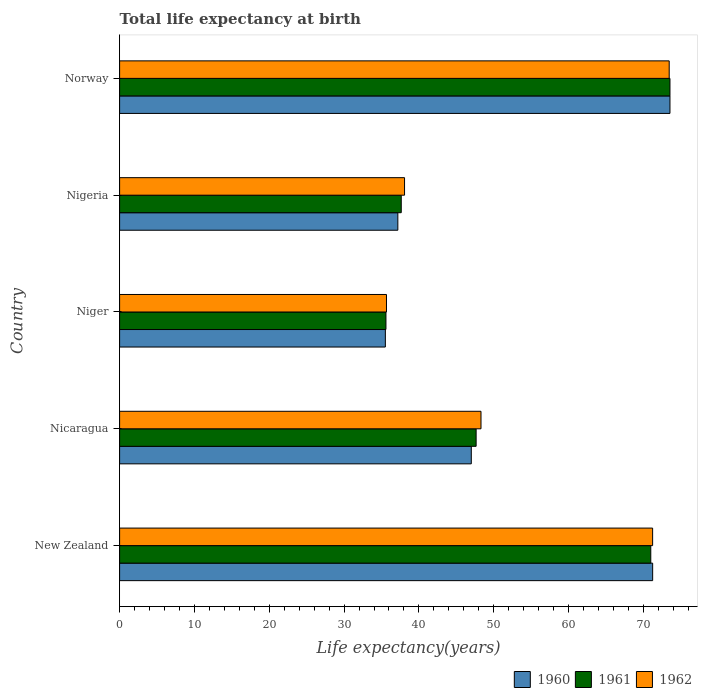How many bars are there on the 1st tick from the bottom?
Your answer should be very brief. 3. What is the label of the 3rd group of bars from the top?
Keep it short and to the point. Niger. In how many cases, is the number of bars for a given country not equal to the number of legend labels?
Give a very brief answer. 0. What is the life expectancy at birth in in 1962 in Nigeria?
Ensure brevity in your answer.  38.08. Across all countries, what is the maximum life expectancy at birth in in 1960?
Provide a short and direct response. 73.55. Across all countries, what is the minimum life expectancy at birth in in 1962?
Give a very brief answer. 35.67. In which country was the life expectancy at birth in in 1962 minimum?
Your answer should be very brief. Niger. What is the total life expectancy at birth in in 1962 in the graph?
Provide a short and direct response. 266.72. What is the difference between the life expectancy at birth in in 1962 in New Zealand and that in Nigeria?
Make the answer very short. 33.15. What is the difference between the life expectancy at birth in in 1960 in Nicaragua and the life expectancy at birth in in 1962 in Niger?
Offer a very short reply. 11.33. What is the average life expectancy at birth in in 1960 per country?
Your answer should be compact. 52.9. What is the difference between the life expectancy at birth in in 1960 and life expectancy at birth in in 1962 in Norway?
Your answer should be compact. 0.1. In how many countries, is the life expectancy at birth in in 1962 greater than 28 years?
Give a very brief answer. 5. What is the ratio of the life expectancy at birth in in 1960 in Nicaragua to that in Norway?
Offer a very short reply. 0.64. Is the difference between the life expectancy at birth in in 1960 in New Zealand and Nigeria greater than the difference between the life expectancy at birth in in 1962 in New Zealand and Nigeria?
Provide a short and direct response. Yes. What is the difference between the highest and the second highest life expectancy at birth in in 1962?
Give a very brief answer. 2.22. What is the difference between the highest and the lowest life expectancy at birth in in 1961?
Provide a short and direct response. 37.96. Is it the case that in every country, the sum of the life expectancy at birth in in 1962 and life expectancy at birth in in 1961 is greater than the life expectancy at birth in in 1960?
Your answer should be very brief. Yes. Are all the bars in the graph horizontal?
Make the answer very short. Yes. How many countries are there in the graph?
Offer a terse response. 5. Where does the legend appear in the graph?
Offer a terse response. Bottom right. How many legend labels are there?
Offer a very short reply. 3. What is the title of the graph?
Your response must be concise. Total life expectancy at birth. Does "1974" appear as one of the legend labels in the graph?
Your answer should be compact. No. What is the label or title of the X-axis?
Your answer should be compact. Life expectancy(years). What is the Life expectancy(years) in 1960 in New Zealand?
Offer a terse response. 71.24. What is the Life expectancy(years) in 1961 in New Zealand?
Provide a short and direct response. 70.99. What is the Life expectancy(years) in 1962 in New Zealand?
Offer a very short reply. 71.23. What is the Life expectancy(years) in 1960 in Nicaragua?
Provide a short and direct response. 47. What is the Life expectancy(years) of 1961 in Nicaragua?
Your response must be concise. 47.65. What is the Life expectancy(years) in 1962 in Nicaragua?
Give a very brief answer. 48.3. What is the Life expectancy(years) of 1960 in Niger?
Offer a terse response. 35.52. What is the Life expectancy(years) of 1961 in Niger?
Provide a succinct answer. 35.59. What is the Life expectancy(years) in 1962 in Niger?
Give a very brief answer. 35.67. What is the Life expectancy(years) of 1960 in Nigeria?
Provide a succinct answer. 37.18. What is the Life expectancy(years) of 1961 in Nigeria?
Keep it short and to the point. 37.64. What is the Life expectancy(years) of 1962 in Nigeria?
Your response must be concise. 38.08. What is the Life expectancy(years) in 1960 in Norway?
Your answer should be very brief. 73.55. What is the Life expectancy(years) of 1961 in Norway?
Keep it short and to the point. 73.55. What is the Life expectancy(years) of 1962 in Norway?
Offer a terse response. 73.45. Across all countries, what is the maximum Life expectancy(years) of 1960?
Provide a succinct answer. 73.55. Across all countries, what is the maximum Life expectancy(years) of 1961?
Offer a very short reply. 73.55. Across all countries, what is the maximum Life expectancy(years) in 1962?
Offer a very short reply. 73.45. Across all countries, what is the minimum Life expectancy(years) of 1960?
Give a very brief answer. 35.52. Across all countries, what is the minimum Life expectancy(years) in 1961?
Your answer should be very brief. 35.59. Across all countries, what is the minimum Life expectancy(years) in 1962?
Provide a short and direct response. 35.67. What is the total Life expectancy(years) in 1960 in the graph?
Make the answer very short. 264.48. What is the total Life expectancy(years) of 1961 in the graph?
Keep it short and to the point. 265.41. What is the total Life expectancy(years) in 1962 in the graph?
Ensure brevity in your answer.  266.72. What is the difference between the Life expectancy(years) in 1960 in New Zealand and that in Nicaragua?
Provide a succinct answer. 24.24. What is the difference between the Life expectancy(years) in 1961 in New Zealand and that in Nicaragua?
Offer a very short reply. 23.34. What is the difference between the Life expectancy(years) in 1962 in New Zealand and that in Nicaragua?
Provide a succinct answer. 22.94. What is the difference between the Life expectancy(years) of 1960 in New Zealand and that in Niger?
Make the answer very short. 35.72. What is the difference between the Life expectancy(years) in 1961 in New Zealand and that in Niger?
Your answer should be compact. 35.39. What is the difference between the Life expectancy(years) in 1962 in New Zealand and that in Niger?
Provide a succinct answer. 35.57. What is the difference between the Life expectancy(years) in 1960 in New Zealand and that in Nigeria?
Provide a short and direct response. 34.05. What is the difference between the Life expectancy(years) of 1961 in New Zealand and that in Nigeria?
Your answer should be very brief. 33.35. What is the difference between the Life expectancy(years) of 1962 in New Zealand and that in Nigeria?
Offer a very short reply. 33.15. What is the difference between the Life expectancy(years) in 1960 in New Zealand and that in Norway?
Provide a succinct answer. -2.31. What is the difference between the Life expectancy(years) of 1961 in New Zealand and that in Norway?
Offer a very short reply. -2.57. What is the difference between the Life expectancy(years) of 1962 in New Zealand and that in Norway?
Offer a terse response. -2.22. What is the difference between the Life expectancy(years) in 1960 in Nicaragua and that in Niger?
Offer a terse response. 11.48. What is the difference between the Life expectancy(years) in 1961 in Nicaragua and that in Niger?
Provide a succinct answer. 12.05. What is the difference between the Life expectancy(years) in 1962 in Nicaragua and that in Niger?
Provide a succinct answer. 12.63. What is the difference between the Life expectancy(years) of 1960 in Nicaragua and that in Nigeria?
Provide a succinct answer. 9.82. What is the difference between the Life expectancy(years) in 1961 in Nicaragua and that in Nigeria?
Provide a short and direct response. 10.01. What is the difference between the Life expectancy(years) of 1962 in Nicaragua and that in Nigeria?
Your response must be concise. 10.22. What is the difference between the Life expectancy(years) of 1960 in Nicaragua and that in Norway?
Make the answer very short. -26.55. What is the difference between the Life expectancy(years) of 1961 in Nicaragua and that in Norway?
Ensure brevity in your answer.  -25.9. What is the difference between the Life expectancy(years) of 1962 in Nicaragua and that in Norway?
Your answer should be very brief. -25.15. What is the difference between the Life expectancy(years) in 1960 in Niger and that in Nigeria?
Give a very brief answer. -1.67. What is the difference between the Life expectancy(years) of 1961 in Niger and that in Nigeria?
Your answer should be very brief. -2.04. What is the difference between the Life expectancy(years) in 1962 in Niger and that in Nigeria?
Provide a succinct answer. -2.41. What is the difference between the Life expectancy(years) of 1960 in Niger and that in Norway?
Your response must be concise. -38.03. What is the difference between the Life expectancy(years) in 1961 in Niger and that in Norway?
Your answer should be very brief. -37.96. What is the difference between the Life expectancy(years) of 1962 in Niger and that in Norway?
Keep it short and to the point. -37.78. What is the difference between the Life expectancy(years) of 1960 in Nigeria and that in Norway?
Offer a very short reply. -36.37. What is the difference between the Life expectancy(years) of 1961 in Nigeria and that in Norway?
Ensure brevity in your answer.  -35.91. What is the difference between the Life expectancy(years) of 1962 in Nigeria and that in Norway?
Your answer should be very brief. -35.37. What is the difference between the Life expectancy(years) in 1960 in New Zealand and the Life expectancy(years) in 1961 in Nicaragua?
Give a very brief answer. 23.59. What is the difference between the Life expectancy(years) in 1960 in New Zealand and the Life expectancy(years) in 1962 in Nicaragua?
Your response must be concise. 22.94. What is the difference between the Life expectancy(years) in 1961 in New Zealand and the Life expectancy(years) in 1962 in Nicaragua?
Ensure brevity in your answer.  22.69. What is the difference between the Life expectancy(years) of 1960 in New Zealand and the Life expectancy(years) of 1961 in Niger?
Offer a very short reply. 35.64. What is the difference between the Life expectancy(years) of 1960 in New Zealand and the Life expectancy(years) of 1962 in Niger?
Offer a terse response. 35.57. What is the difference between the Life expectancy(years) in 1961 in New Zealand and the Life expectancy(years) in 1962 in Niger?
Give a very brief answer. 35.32. What is the difference between the Life expectancy(years) in 1960 in New Zealand and the Life expectancy(years) in 1961 in Nigeria?
Offer a terse response. 33.6. What is the difference between the Life expectancy(years) of 1960 in New Zealand and the Life expectancy(years) of 1962 in Nigeria?
Give a very brief answer. 33.16. What is the difference between the Life expectancy(years) in 1961 in New Zealand and the Life expectancy(years) in 1962 in Nigeria?
Offer a terse response. 32.91. What is the difference between the Life expectancy(years) in 1960 in New Zealand and the Life expectancy(years) in 1961 in Norway?
Your response must be concise. -2.31. What is the difference between the Life expectancy(years) in 1960 in New Zealand and the Life expectancy(years) in 1962 in Norway?
Provide a short and direct response. -2.21. What is the difference between the Life expectancy(years) in 1961 in New Zealand and the Life expectancy(years) in 1962 in Norway?
Offer a terse response. -2.46. What is the difference between the Life expectancy(years) of 1960 in Nicaragua and the Life expectancy(years) of 1961 in Niger?
Make the answer very short. 11.4. What is the difference between the Life expectancy(years) of 1960 in Nicaragua and the Life expectancy(years) of 1962 in Niger?
Give a very brief answer. 11.33. What is the difference between the Life expectancy(years) in 1961 in Nicaragua and the Life expectancy(years) in 1962 in Niger?
Offer a very short reply. 11.98. What is the difference between the Life expectancy(years) of 1960 in Nicaragua and the Life expectancy(years) of 1961 in Nigeria?
Your answer should be very brief. 9.36. What is the difference between the Life expectancy(years) of 1960 in Nicaragua and the Life expectancy(years) of 1962 in Nigeria?
Provide a short and direct response. 8.92. What is the difference between the Life expectancy(years) in 1961 in Nicaragua and the Life expectancy(years) in 1962 in Nigeria?
Make the answer very short. 9.57. What is the difference between the Life expectancy(years) in 1960 in Nicaragua and the Life expectancy(years) in 1961 in Norway?
Make the answer very short. -26.55. What is the difference between the Life expectancy(years) of 1960 in Nicaragua and the Life expectancy(years) of 1962 in Norway?
Make the answer very short. -26.45. What is the difference between the Life expectancy(years) in 1961 in Nicaragua and the Life expectancy(years) in 1962 in Norway?
Keep it short and to the point. -25.8. What is the difference between the Life expectancy(years) of 1960 in Niger and the Life expectancy(years) of 1961 in Nigeria?
Give a very brief answer. -2.12. What is the difference between the Life expectancy(years) of 1960 in Niger and the Life expectancy(years) of 1962 in Nigeria?
Your response must be concise. -2.56. What is the difference between the Life expectancy(years) of 1961 in Niger and the Life expectancy(years) of 1962 in Nigeria?
Ensure brevity in your answer.  -2.48. What is the difference between the Life expectancy(years) in 1960 in Niger and the Life expectancy(years) in 1961 in Norway?
Your answer should be compact. -38.04. What is the difference between the Life expectancy(years) of 1960 in Niger and the Life expectancy(years) of 1962 in Norway?
Ensure brevity in your answer.  -37.93. What is the difference between the Life expectancy(years) in 1961 in Niger and the Life expectancy(years) in 1962 in Norway?
Make the answer very short. -37.85. What is the difference between the Life expectancy(years) of 1960 in Nigeria and the Life expectancy(years) of 1961 in Norway?
Keep it short and to the point. -36.37. What is the difference between the Life expectancy(years) of 1960 in Nigeria and the Life expectancy(years) of 1962 in Norway?
Offer a terse response. -36.27. What is the difference between the Life expectancy(years) of 1961 in Nigeria and the Life expectancy(years) of 1962 in Norway?
Offer a terse response. -35.81. What is the average Life expectancy(years) in 1960 per country?
Make the answer very short. 52.9. What is the average Life expectancy(years) of 1961 per country?
Your answer should be very brief. 53.08. What is the average Life expectancy(years) in 1962 per country?
Give a very brief answer. 53.34. What is the difference between the Life expectancy(years) of 1960 and Life expectancy(years) of 1961 in New Zealand?
Provide a short and direct response. 0.25. What is the difference between the Life expectancy(years) of 1960 and Life expectancy(years) of 1962 in New Zealand?
Ensure brevity in your answer.  0. What is the difference between the Life expectancy(years) in 1961 and Life expectancy(years) in 1962 in New Zealand?
Provide a succinct answer. -0.25. What is the difference between the Life expectancy(years) of 1960 and Life expectancy(years) of 1961 in Nicaragua?
Provide a succinct answer. -0.65. What is the difference between the Life expectancy(years) of 1960 and Life expectancy(years) of 1962 in Nicaragua?
Offer a terse response. -1.3. What is the difference between the Life expectancy(years) of 1961 and Life expectancy(years) of 1962 in Nicaragua?
Offer a very short reply. -0.65. What is the difference between the Life expectancy(years) of 1960 and Life expectancy(years) of 1961 in Niger?
Make the answer very short. -0.08. What is the difference between the Life expectancy(years) of 1960 and Life expectancy(years) of 1962 in Niger?
Give a very brief answer. -0.15. What is the difference between the Life expectancy(years) of 1961 and Life expectancy(years) of 1962 in Niger?
Provide a succinct answer. -0.07. What is the difference between the Life expectancy(years) in 1960 and Life expectancy(years) in 1961 in Nigeria?
Offer a very short reply. -0.46. What is the difference between the Life expectancy(years) in 1960 and Life expectancy(years) in 1962 in Nigeria?
Make the answer very short. -0.9. What is the difference between the Life expectancy(years) in 1961 and Life expectancy(years) in 1962 in Nigeria?
Your answer should be very brief. -0.44. What is the difference between the Life expectancy(years) in 1960 and Life expectancy(years) in 1961 in Norway?
Make the answer very short. -0. What is the difference between the Life expectancy(years) of 1960 and Life expectancy(years) of 1962 in Norway?
Provide a succinct answer. 0.1. What is the difference between the Life expectancy(years) in 1961 and Life expectancy(years) in 1962 in Norway?
Give a very brief answer. 0.1. What is the ratio of the Life expectancy(years) of 1960 in New Zealand to that in Nicaragua?
Ensure brevity in your answer.  1.52. What is the ratio of the Life expectancy(years) of 1961 in New Zealand to that in Nicaragua?
Offer a terse response. 1.49. What is the ratio of the Life expectancy(years) of 1962 in New Zealand to that in Nicaragua?
Offer a very short reply. 1.47. What is the ratio of the Life expectancy(years) of 1960 in New Zealand to that in Niger?
Make the answer very short. 2.01. What is the ratio of the Life expectancy(years) of 1961 in New Zealand to that in Niger?
Provide a succinct answer. 1.99. What is the ratio of the Life expectancy(years) of 1962 in New Zealand to that in Niger?
Ensure brevity in your answer.  2. What is the ratio of the Life expectancy(years) of 1960 in New Zealand to that in Nigeria?
Make the answer very short. 1.92. What is the ratio of the Life expectancy(years) in 1961 in New Zealand to that in Nigeria?
Make the answer very short. 1.89. What is the ratio of the Life expectancy(years) of 1962 in New Zealand to that in Nigeria?
Offer a terse response. 1.87. What is the ratio of the Life expectancy(years) of 1960 in New Zealand to that in Norway?
Your response must be concise. 0.97. What is the ratio of the Life expectancy(years) of 1961 in New Zealand to that in Norway?
Provide a succinct answer. 0.97. What is the ratio of the Life expectancy(years) in 1962 in New Zealand to that in Norway?
Keep it short and to the point. 0.97. What is the ratio of the Life expectancy(years) in 1960 in Nicaragua to that in Niger?
Offer a very short reply. 1.32. What is the ratio of the Life expectancy(years) in 1961 in Nicaragua to that in Niger?
Make the answer very short. 1.34. What is the ratio of the Life expectancy(years) in 1962 in Nicaragua to that in Niger?
Offer a terse response. 1.35. What is the ratio of the Life expectancy(years) of 1960 in Nicaragua to that in Nigeria?
Your response must be concise. 1.26. What is the ratio of the Life expectancy(years) of 1961 in Nicaragua to that in Nigeria?
Keep it short and to the point. 1.27. What is the ratio of the Life expectancy(years) in 1962 in Nicaragua to that in Nigeria?
Ensure brevity in your answer.  1.27. What is the ratio of the Life expectancy(years) in 1960 in Nicaragua to that in Norway?
Make the answer very short. 0.64. What is the ratio of the Life expectancy(years) of 1961 in Nicaragua to that in Norway?
Keep it short and to the point. 0.65. What is the ratio of the Life expectancy(years) of 1962 in Nicaragua to that in Norway?
Your answer should be very brief. 0.66. What is the ratio of the Life expectancy(years) of 1960 in Niger to that in Nigeria?
Keep it short and to the point. 0.96. What is the ratio of the Life expectancy(years) of 1961 in Niger to that in Nigeria?
Give a very brief answer. 0.95. What is the ratio of the Life expectancy(years) in 1962 in Niger to that in Nigeria?
Give a very brief answer. 0.94. What is the ratio of the Life expectancy(years) in 1960 in Niger to that in Norway?
Keep it short and to the point. 0.48. What is the ratio of the Life expectancy(years) in 1961 in Niger to that in Norway?
Your answer should be compact. 0.48. What is the ratio of the Life expectancy(years) in 1962 in Niger to that in Norway?
Ensure brevity in your answer.  0.49. What is the ratio of the Life expectancy(years) of 1960 in Nigeria to that in Norway?
Make the answer very short. 0.51. What is the ratio of the Life expectancy(years) of 1961 in Nigeria to that in Norway?
Make the answer very short. 0.51. What is the ratio of the Life expectancy(years) of 1962 in Nigeria to that in Norway?
Offer a very short reply. 0.52. What is the difference between the highest and the second highest Life expectancy(years) in 1960?
Your answer should be very brief. 2.31. What is the difference between the highest and the second highest Life expectancy(years) in 1961?
Your answer should be compact. 2.57. What is the difference between the highest and the second highest Life expectancy(years) of 1962?
Provide a succinct answer. 2.22. What is the difference between the highest and the lowest Life expectancy(years) in 1960?
Ensure brevity in your answer.  38.03. What is the difference between the highest and the lowest Life expectancy(years) of 1961?
Offer a very short reply. 37.96. What is the difference between the highest and the lowest Life expectancy(years) in 1962?
Keep it short and to the point. 37.78. 